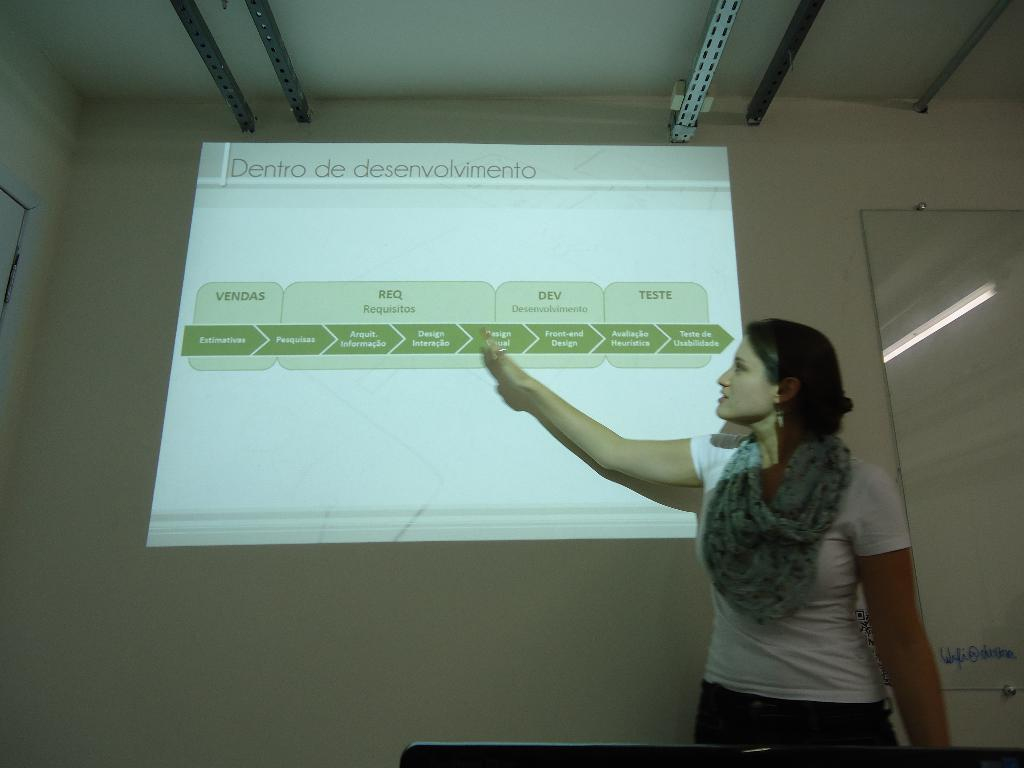<image>
Give a short and clear explanation of the subsequent image. a lady pointing at a dentro slide on the screen 